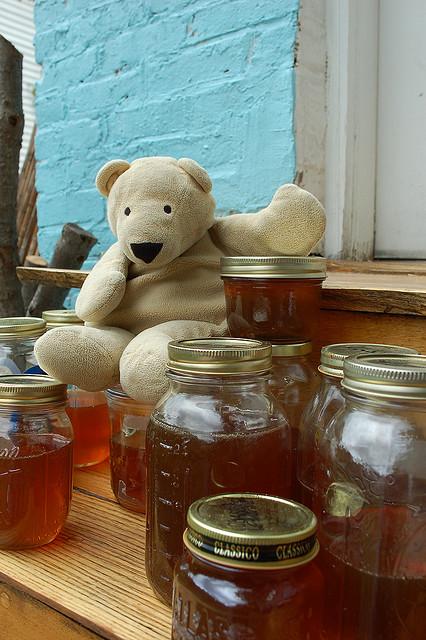How many honey jars are here?
Quick response, please. 10. What is the teddy bear sitting on?
Write a very short answer. Jar. What color is the bear?
Keep it brief. White. 